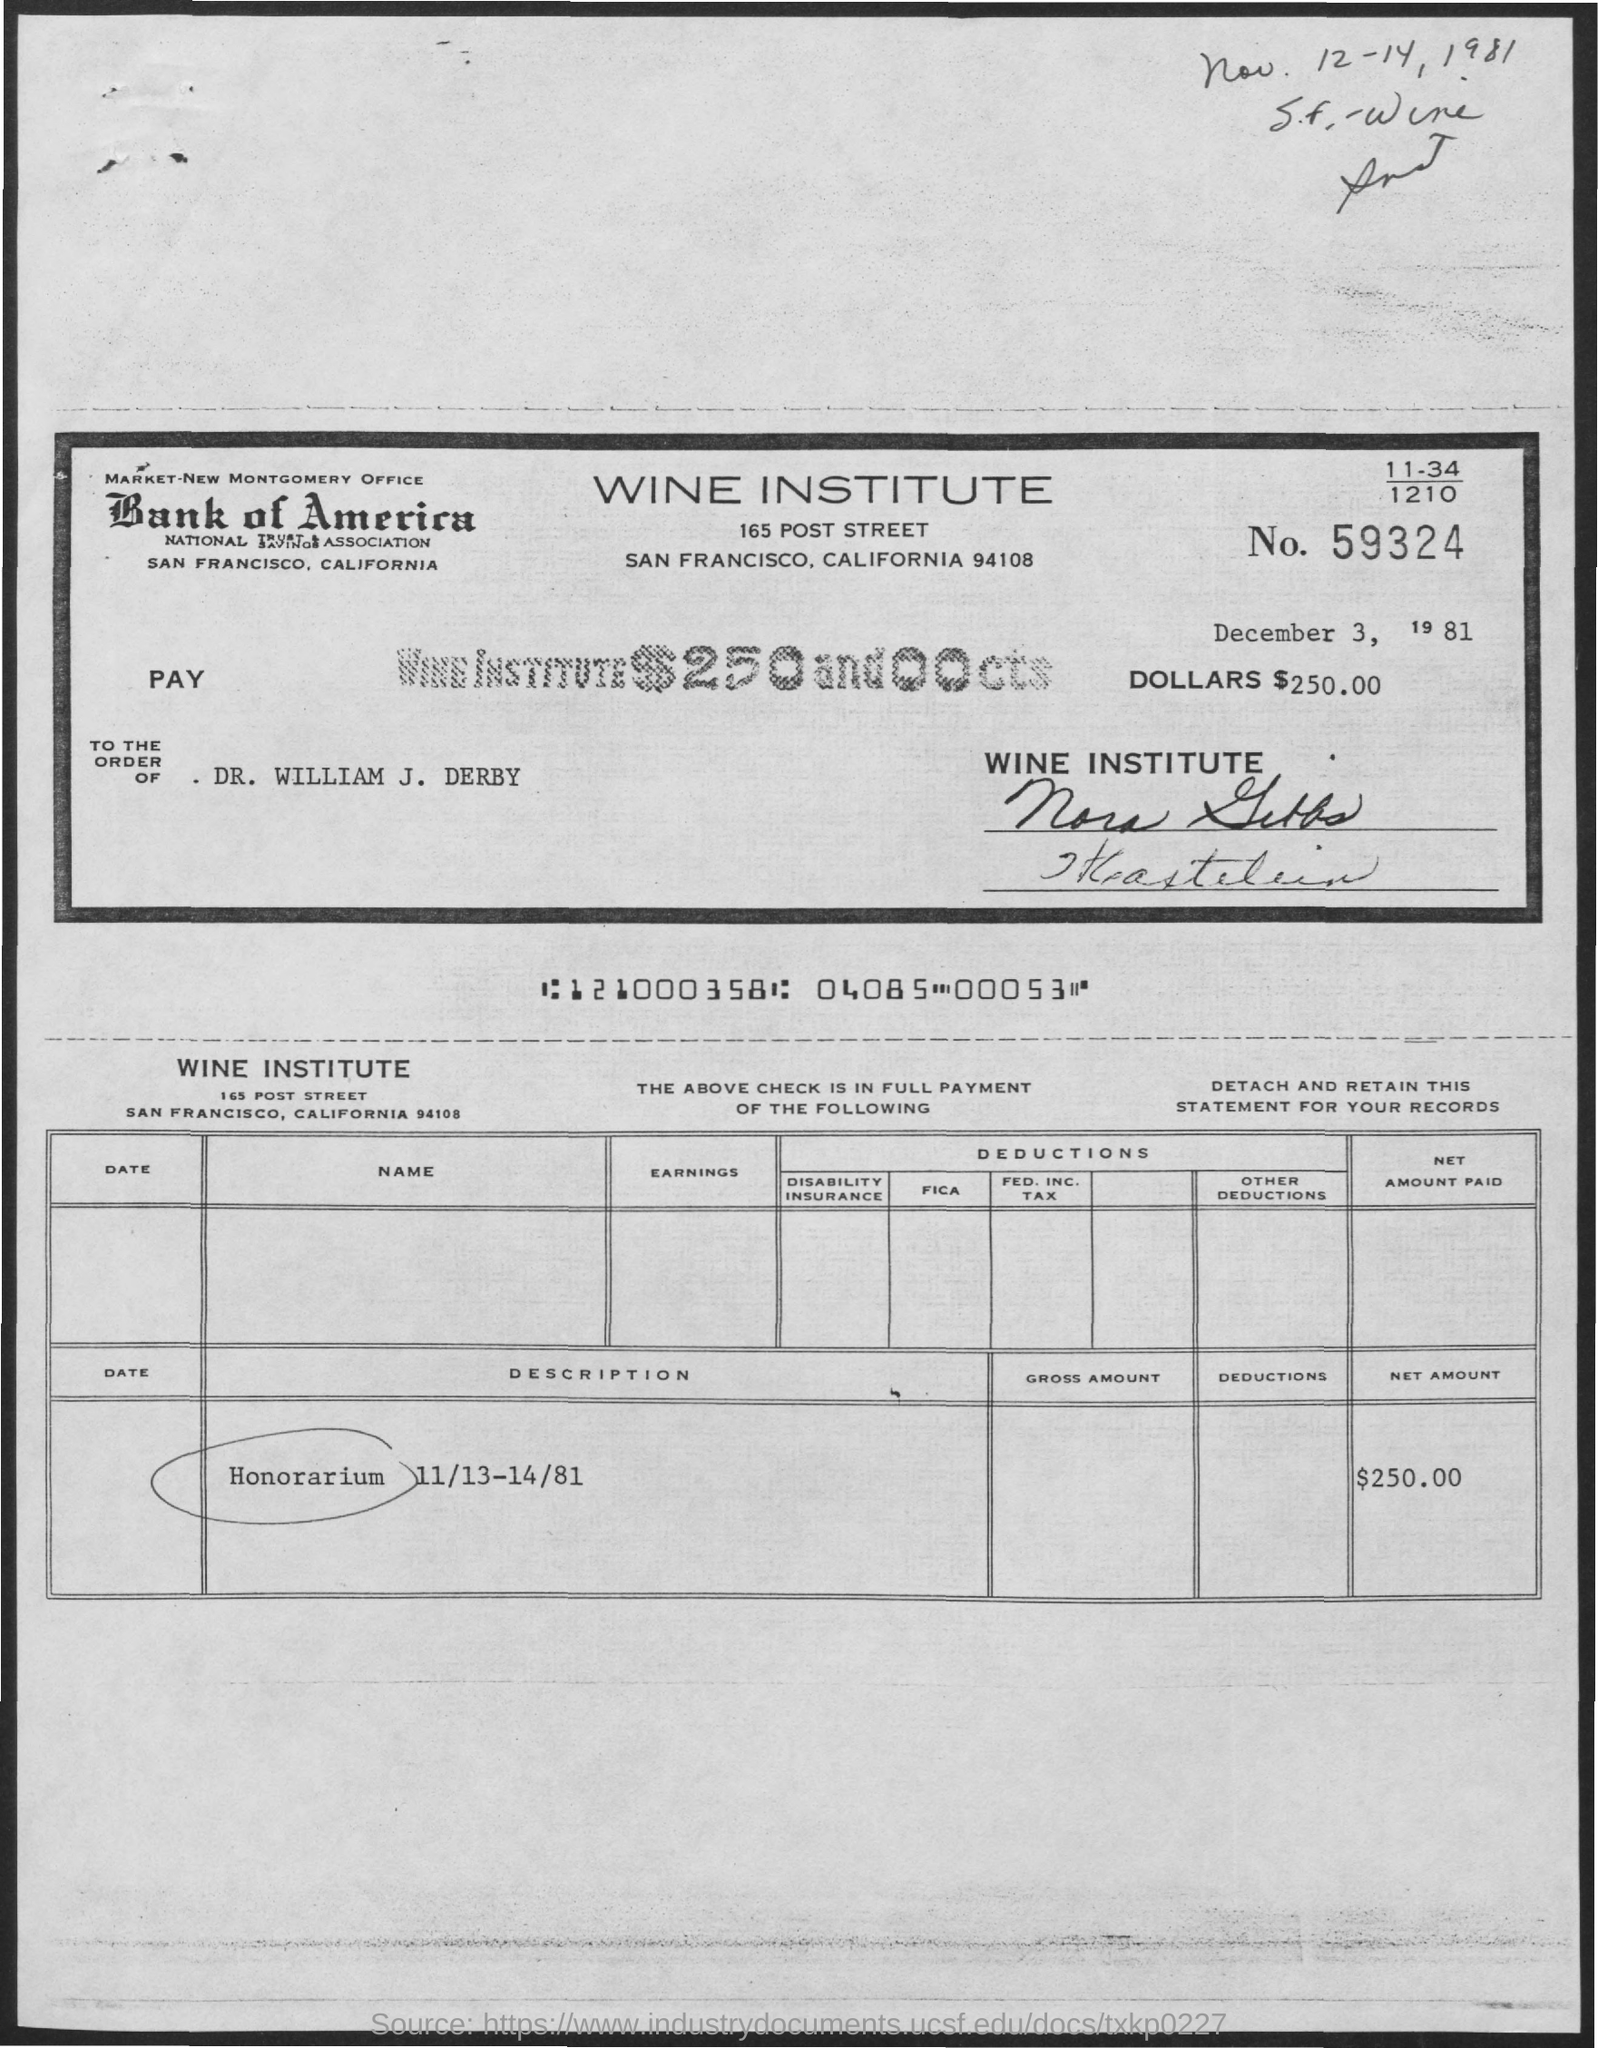What is the Net Amount?
Your answer should be very brief. $250.00. What is the Number?
Provide a short and direct response. 59324. 